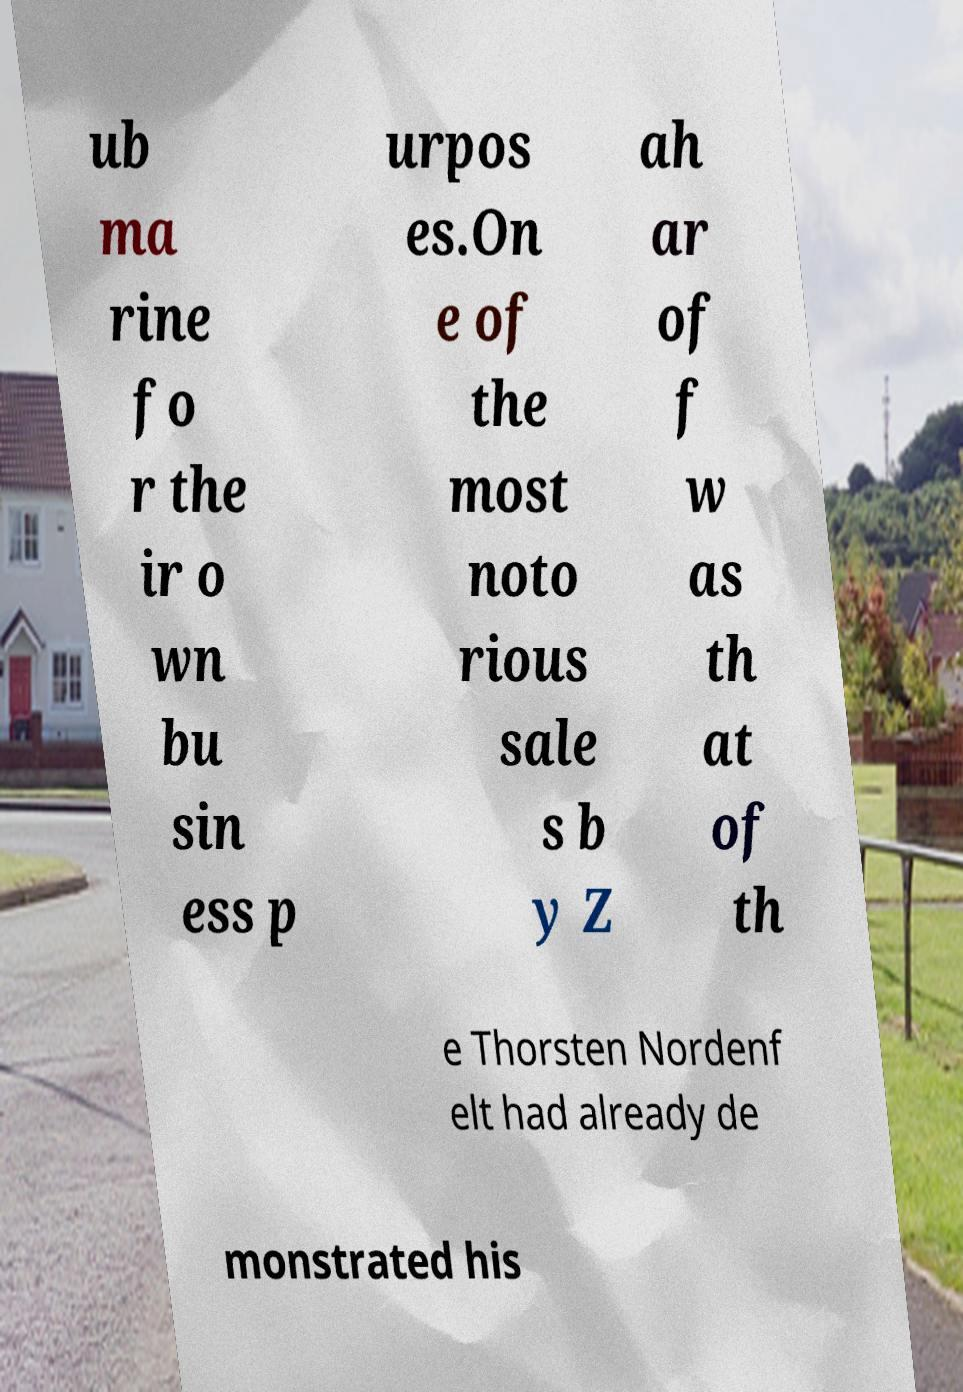Can you accurately transcribe the text from the provided image for me? ub ma rine fo r the ir o wn bu sin ess p urpos es.On e of the most noto rious sale s b y Z ah ar of f w as th at of th e Thorsten Nordenf elt had already de monstrated his 